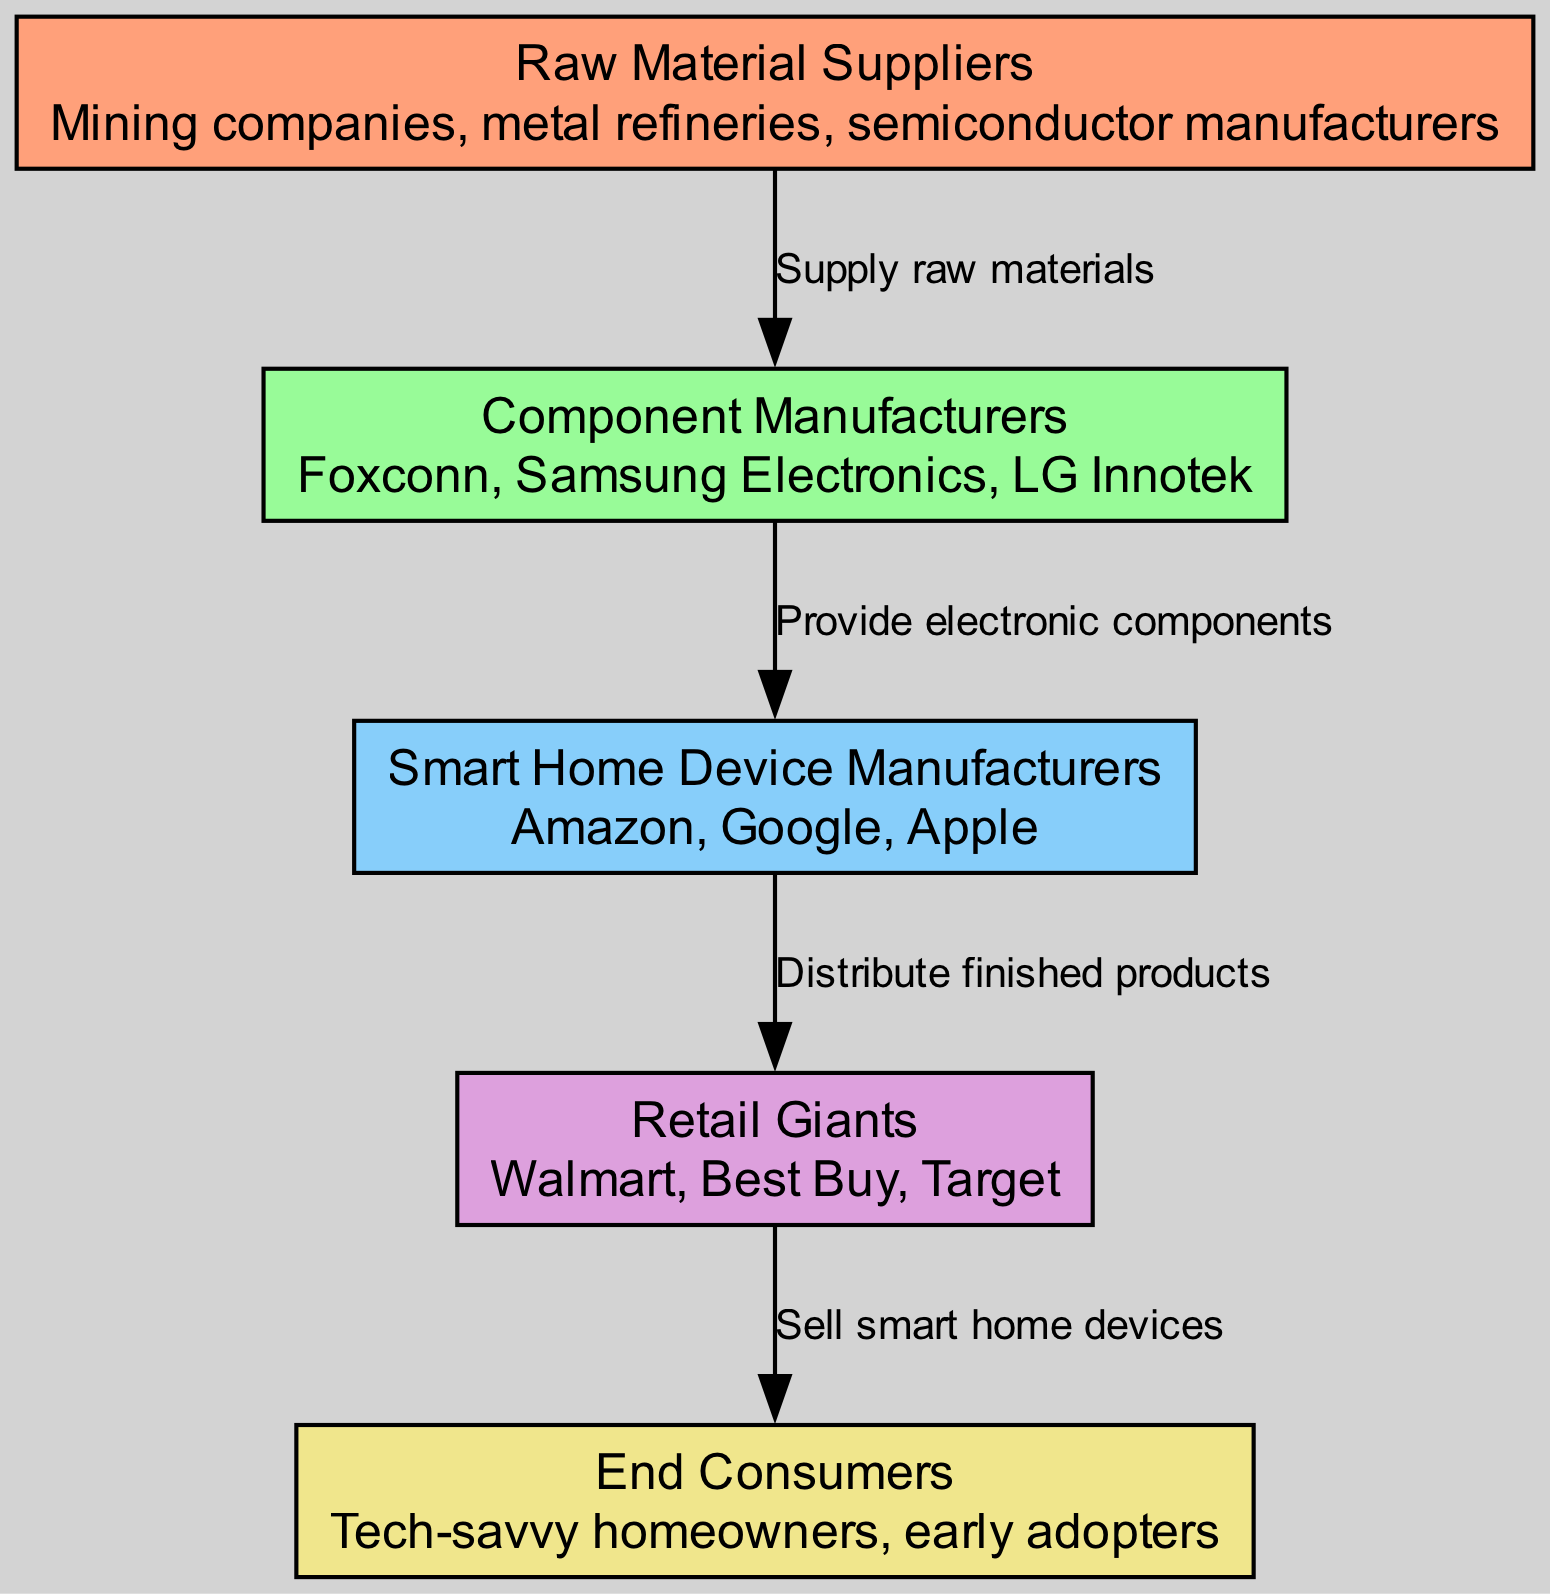What are the nodes in the diagram? The nodes in the diagram are Raw Material Suppliers, Component Manufacturers, Smart Home Device Manufacturers, Retail Giants, and End Consumers. These elements represent different segments in the global sourcing network for electronic components in smart home devices.
Answer: Raw Material Suppliers, Component Manufacturers, Smart Home Device Manufacturers, Retail Giants, End Consumers How many edges are in the diagram? The edges in the diagram represent the relationships between the nodes, which are four in total: from Raw Material Suppliers to Component Manufacturers, from Component Manufacturers to Smart Home Device Manufacturers, from Smart Home Device Manufacturers to Retail Giants, and from Retail Giants to End Consumers. This leads to a total of four edges.
Answer: 4 Who provides electronic components? The Component Manufacturers are the ones who provide electronic components. They act as intermediaries between the raw material suppliers and the smart home device manufacturers.
Answer: Component Manufacturers What is the role of Retail Giants in this network? Retail Giants are responsible for selling smart home devices to the end consumers. They act as the final link in the supply chain, distributing the finished products.
Answer: Sell smart home devices What do Component Manufacturers receive from Raw Material Suppliers? Component Manufacturers receive raw materials from Raw Material Suppliers as they supply the basis needed for manufacturing electronic components.
Answer: Raw materials What is the final destination of smart home devices in the supply chain? The final destination of smart home devices in the supply chain is the End Consumers, specifically targeting tech-savvy homeowners and early adopters.
Answer: End Consumers Which manufacturer distributes finished products? The Smart Home Device Manufacturers distribute finished products. They take the components produced by the Component Manufacturers and package them into complete smart home devices for distribution.
Answer: Smart Home Device Manufacturers What connects Retail Giants to End Consumers? Retail Giants connect to End Consumers through the sale of smart home devices, creating a direct relationship where consumers can purchase the products.
Answer: Sell smart home devices What type of companies are involved in Raw Material Suppliers? The types of companies involved in Raw Material Suppliers include mining companies, metal refineries, and semiconductor manufacturers, all of which supply essential materials for electronic components.
Answer: Mining companies, metal refineries, semiconductor manufacturers 